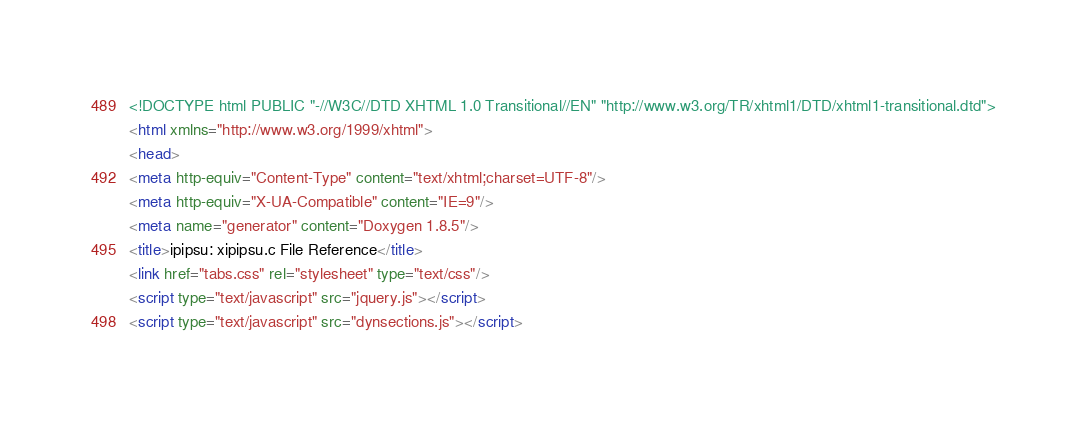<code> <loc_0><loc_0><loc_500><loc_500><_HTML_><!DOCTYPE html PUBLIC "-//W3C//DTD XHTML 1.0 Transitional//EN" "http://www.w3.org/TR/xhtml1/DTD/xhtml1-transitional.dtd">
<html xmlns="http://www.w3.org/1999/xhtml">
<head>
<meta http-equiv="Content-Type" content="text/xhtml;charset=UTF-8"/>
<meta http-equiv="X-UA-Compatible" content="IE=9"/>
<meta name="generator" content="Doxygen 1.8.5"/>
<title>ipipsu: xipipsu.c File Reference</title>
<link href="tabs.css" rel="stylesheet" type="text/css"/>
<script type="text/javascript" src="jquery.js"></script>
<script type="text/javascript" src="dynsections.js"></script></code> 